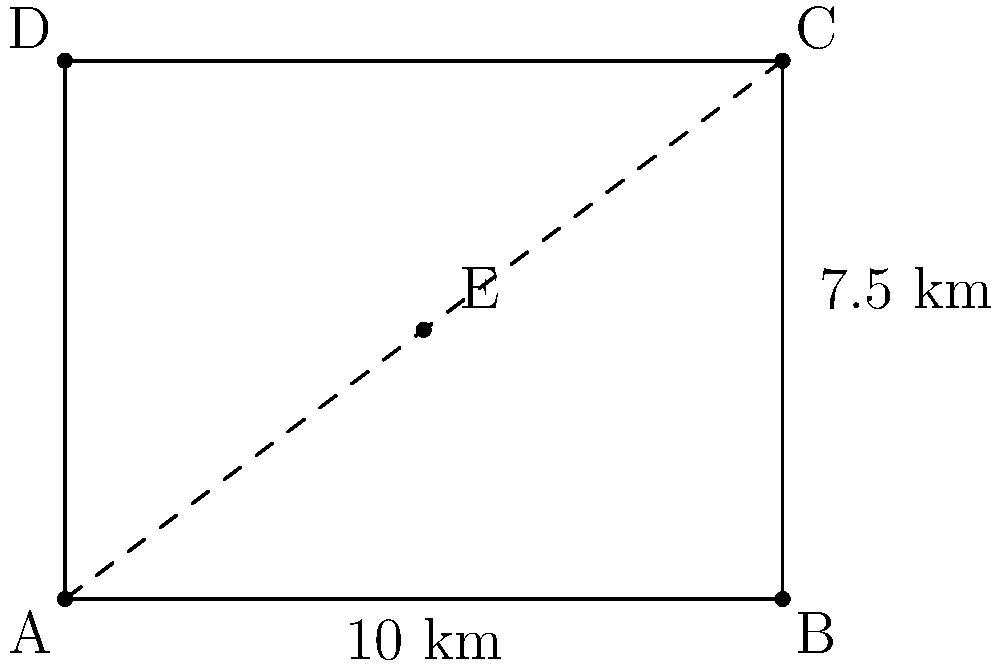A map of dialysis centers in a city is represented by the rectangle ABCD, where AB = 10 km and BC = 7.5 km. Point E represents a new dialysis center. If the map needs to be scaled up by a factor of 1.5 to accommodate more detail for patient travel planning, what will be the area of the new scaled map in square kilometers? To solve this problem, we'll follow these steps:

1) First, let's calculate the original area of the map:
   Area = length × width
   Area = 10 km × 7.5 km = 75 km²

2) Now, we need to apply the scale factor to both dimensions:
   New length = 10 km × 1.5 = 15 km
   New width = 7.5 km × 1.5 = 11.25 km

3) The scaling factor for area is the square of the linear scaling factor:
   Area scaling factor = 1.5² = 2.25

4) We can calculate the new area in two ways:
   a) Using the new dimensions:
      New Area = 15 km × 11.25 km = 168.75 km²
   
   b) Using the area scaling factor:
      New Area = 75 km² × 2.25 = 168.75 km²

Therefore, the area of the new scaled map will be 168.75 km².
Answer: 168.75 km² 